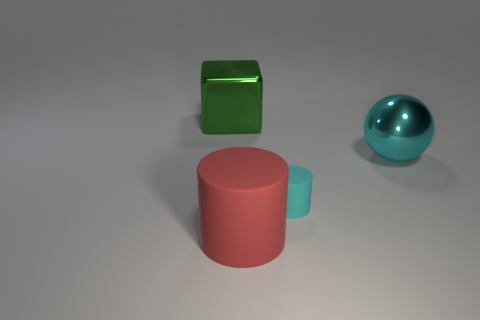Subtract all red blocks. How many red cylinders are left? 1 Add 3 cubes. How many objects exist? 7 Add 4 big gray rubber things. How many big gray rubber things exist? 4 Subtract 0 brown cubes. How many objects are left? 4 Subtract all balls. How many objects are left? 3 Subtract all cyan cylinders. Subtract all cyan spheres. How many cylinders are left? 1 Subtract all cyan things. Subtract all big red rubber objects. How many objects are left? 1 Add 2 shiny cubes. How many shiny cubes are left? 3 